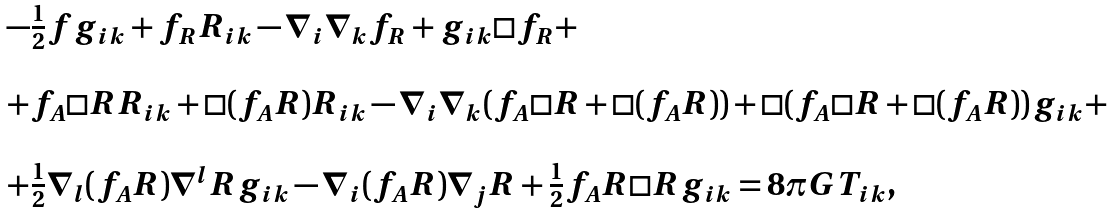<formula> <loc_0><loc_0><loc_500><loc_500>\begin{array} { l } - \frac { 1 } { 2 } f g _ { i k } + f _ { R } R _ { i k } - \nabla _ { i } \nabla _ { k } f _ { R } + g _ { i k } \Box f _ { R } + \\ \\ + f _ { A } \Box R R _ { i k } + \Box ( f _ { A } R ) R _ { i k } - \nabla _ { i } \nabla _ { k } ( f _ { A } \Box R + \Box ( f _ { A } R ) ) + \Box ( f _ { A } \Box R + \Box ( f _ { A } R ) ) g _ { i k } + \\ \\ + \frac { 1 } { 2 } \nabla _ { l } ( f _ { A } R ) \nabla ^ { l } R g _ { i k } - \nabla _ { i } ( f _ { A } R ) \nabla _ { j } R + \frac { 1 } { 2 } f _ { A } R \Box R g _ { i k } = 8 \pi G T _ { i k } , \end{array}</formula> 